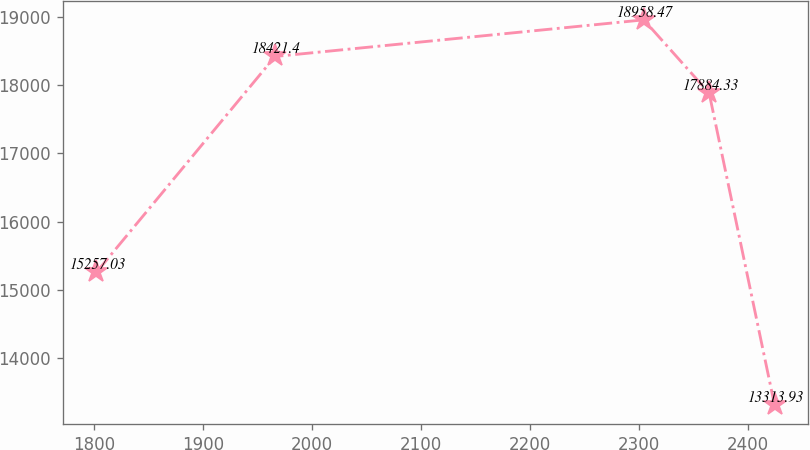<chart> <loc_0><loc_0><loc_500><loc_500><line_chart><ecel><fcel>Unnamed: 1<nl><fcel>1802.32<fcel>15257<nl><fcel>1966.12<fcel>18421.4<nl><fcel>2304.29<fcel>18958.5<nl><fcel>2364.24<fcel>17884.3<nl><fcel>2424.19<fcel>13313.9<nl></chart> 